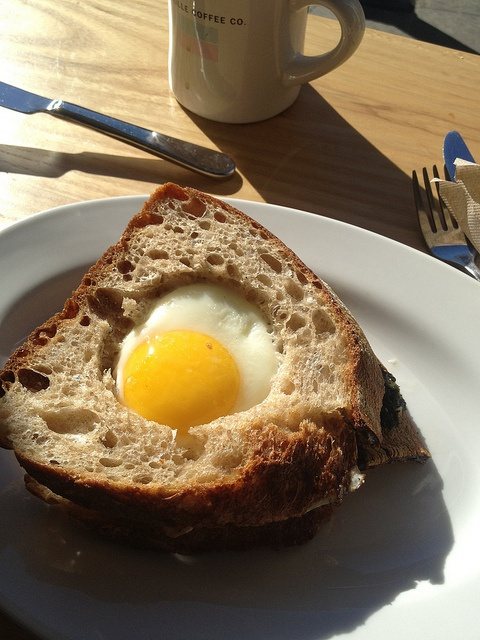Describe the objects in this image and their specific colors. I can see sandwich in ivory, black, tan, and maroon tones, dining table in ivory, tan, black, and beige tones, cup in ivory, gray, and black tones, knife in ivory, black, and gray tones, and fork in ivory, black, gray, and blue tones in this image. 